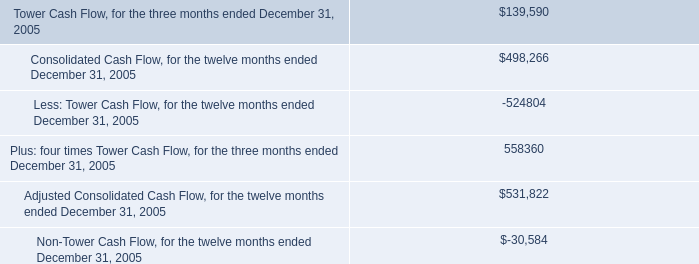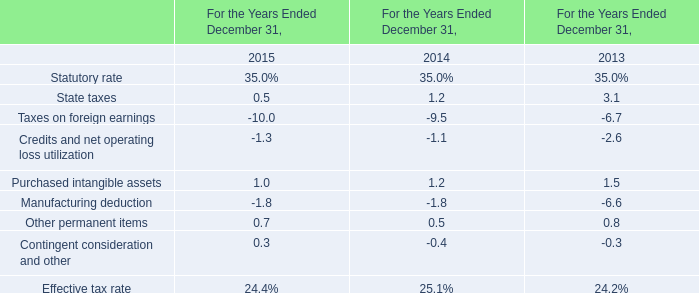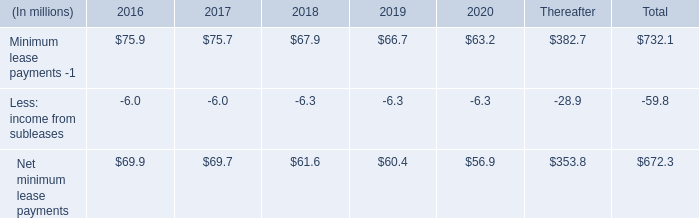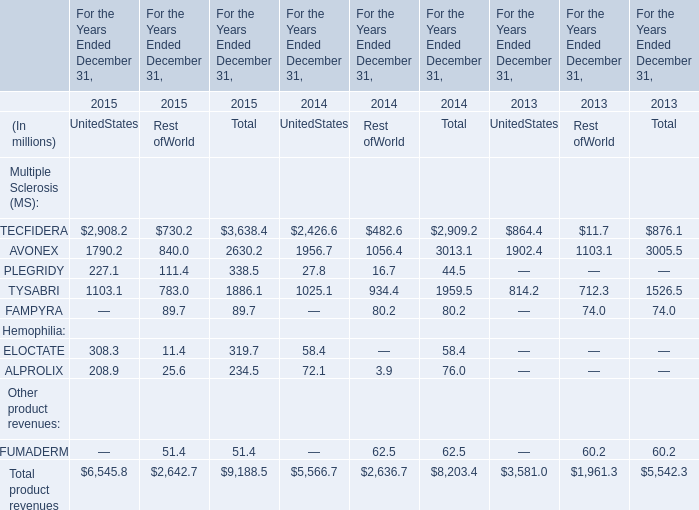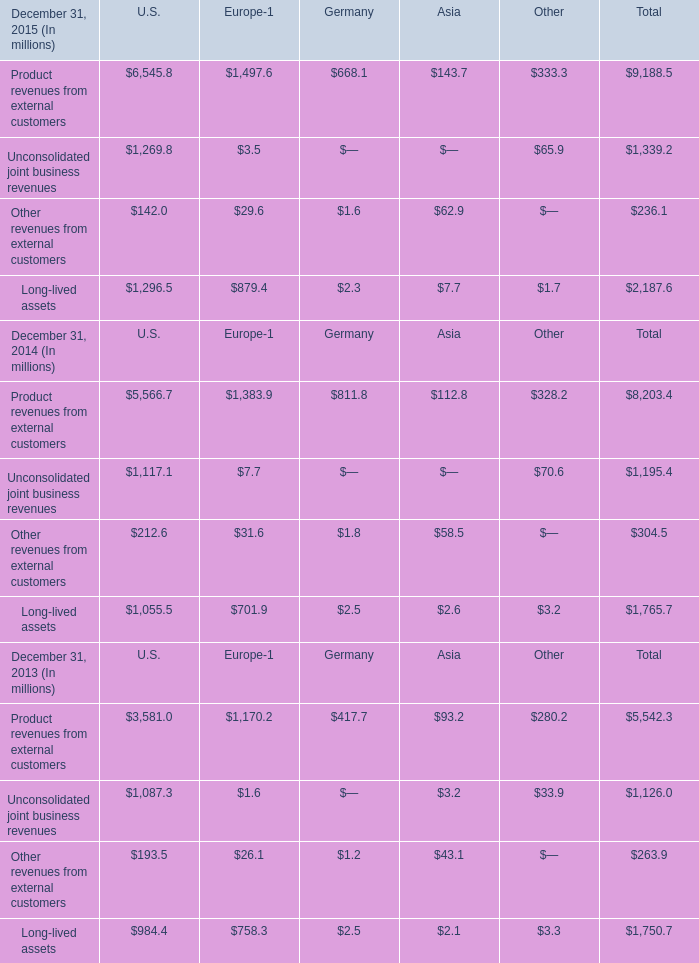Which year is Product revenues from external customers the most? 
Answer: December 31, 2015. 